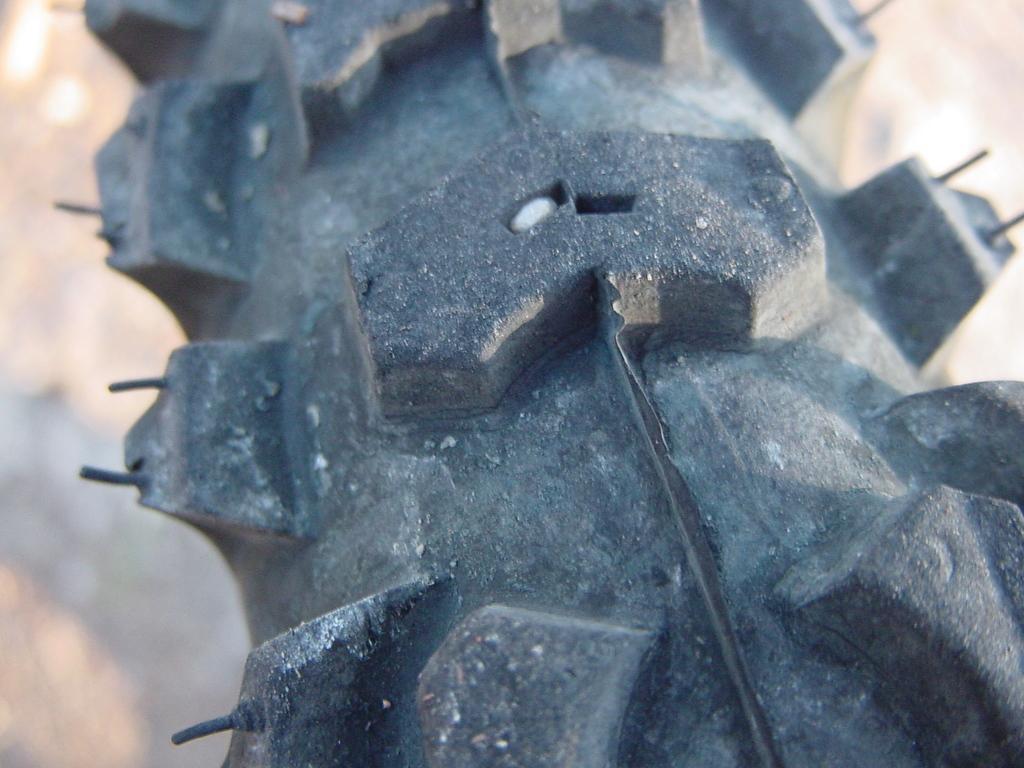In one or two sentences, can you explain what this image depicts? In this image we can see an object looks like a tire and a blurry background. 